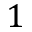<formula> <loc_0><loc_0><loc_500><loc_500>1</formula> 